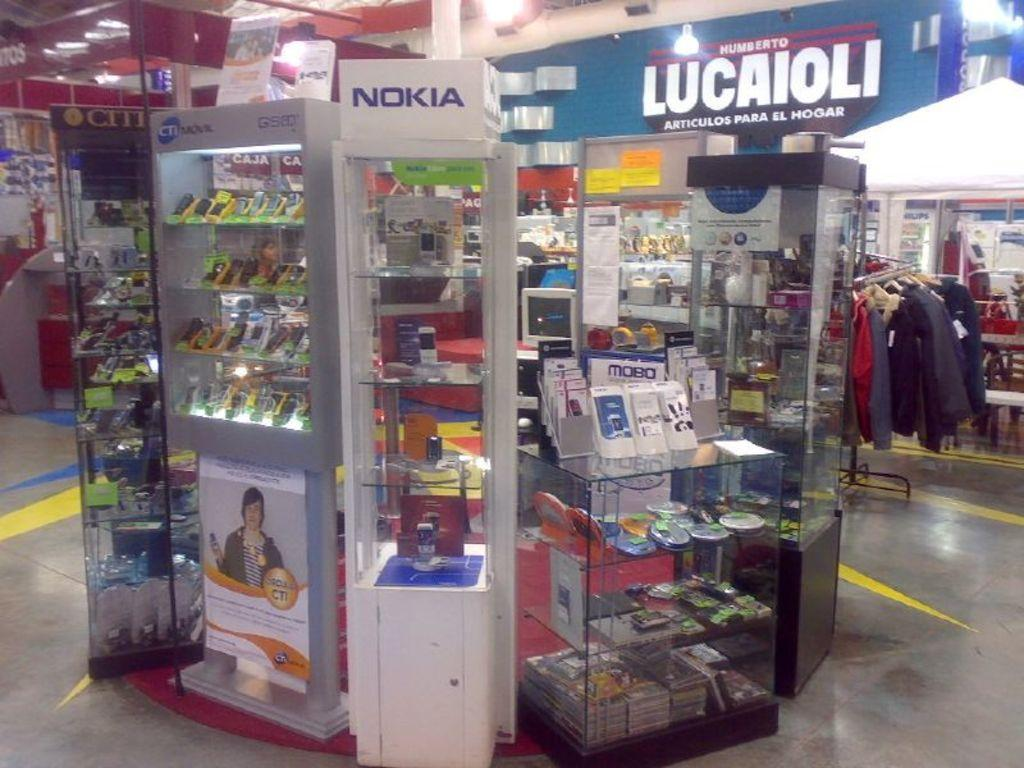<image>
Offer a succinct explanation of the picture presented. A Nokia phone display sits in a circle of other displays and product counters. 